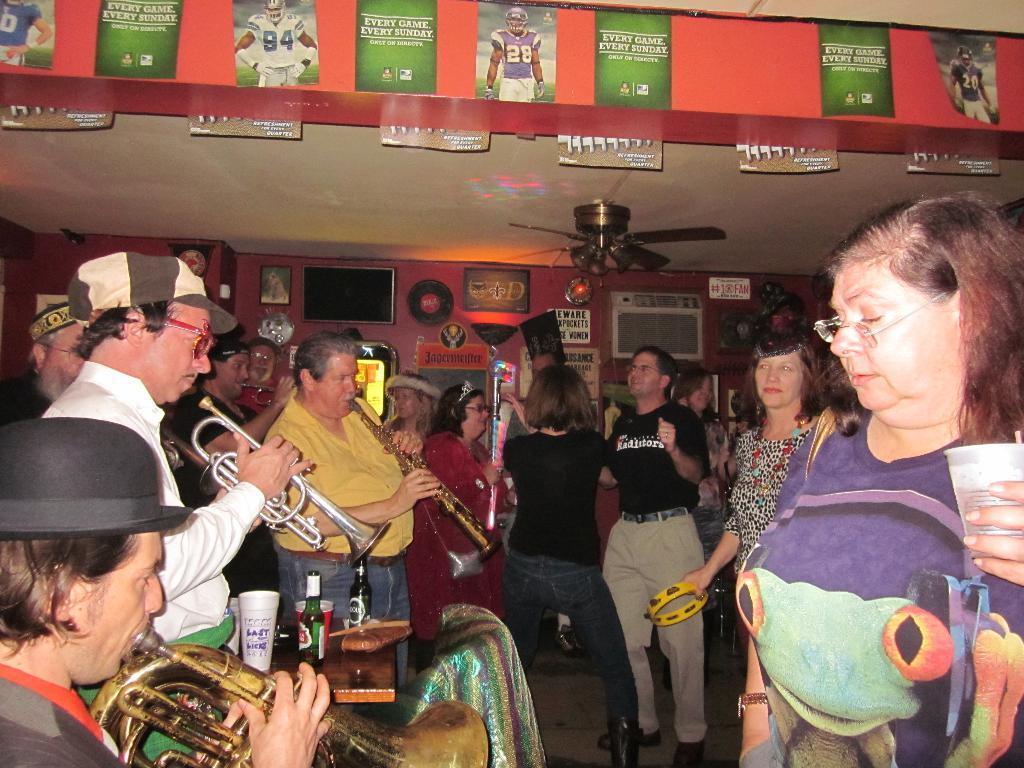Please provide a concise description of this image. Here in this picture we can see a group of people standing on the floor over there and on the left side we can see some men playing musical instruments present in their hands and we can also see glasses and bottles on the table beside them and in the middle we can see some people are dancing over there and on the roof we can see some posters present and we can also see a fan present and on the wall we can see a television, portraits and some posters present over there. 